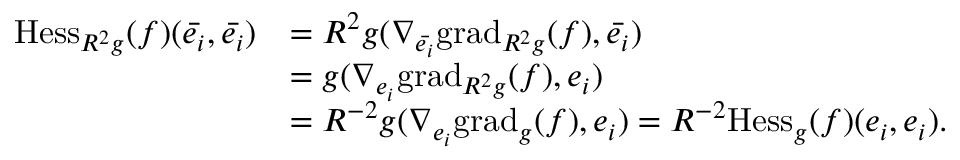<formula> <loc_0><loc_0><loc_500><loc_500>\begin{array} { r l } { H e s s _ { R ^ { 2 } g } ( f ) ( \ B a r { e _ { i } } , \ B a r { e _ { i } } ) } & { = R ^ { 2 } g ( \nabla _ { \ B a r { e _ { i } } } g r a d _ { R ^ { 2 } g } ( f ) , \ B a r { e _ { i } } ) } \\ & { = g ( \nabla _ { { e _ { i } } } g r a d _ { R ^ { 2 } g } ( f ) , e _ { i } ) } \\ & { = R ^ { - 2 } g ( \nabla _ { { e _ { i } } } g r a d _ { g } ( f ) , e _ { i } ) = R ^ { - 2 } H e s s _ { g } ( f ) ( e _ { i } , e _ { i } ) . } \end{array}</formula> 